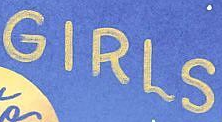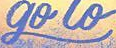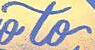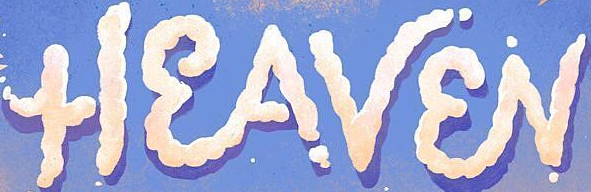What words are shown in these images in order, separated by a semicolon? GIRLS; go; to; HEAVEN 